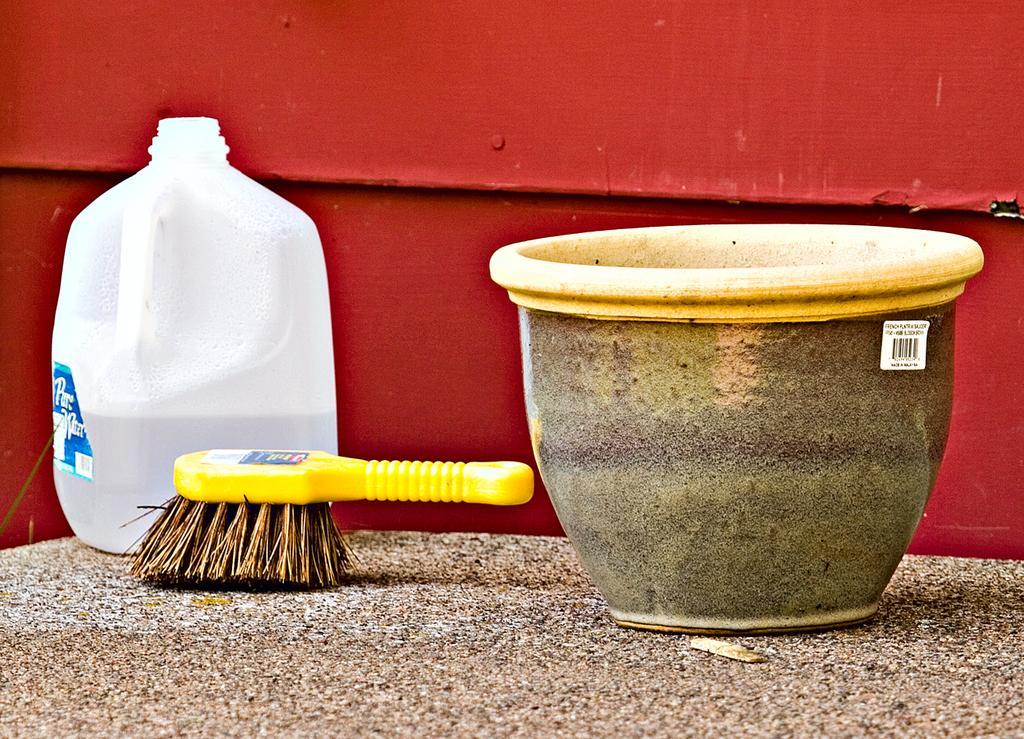Describe this image in one or two sentences. In the picture I can see a clay pot, a brush and water storage Kane on the marble table. I can see the metal block which is painted with red color paint. 